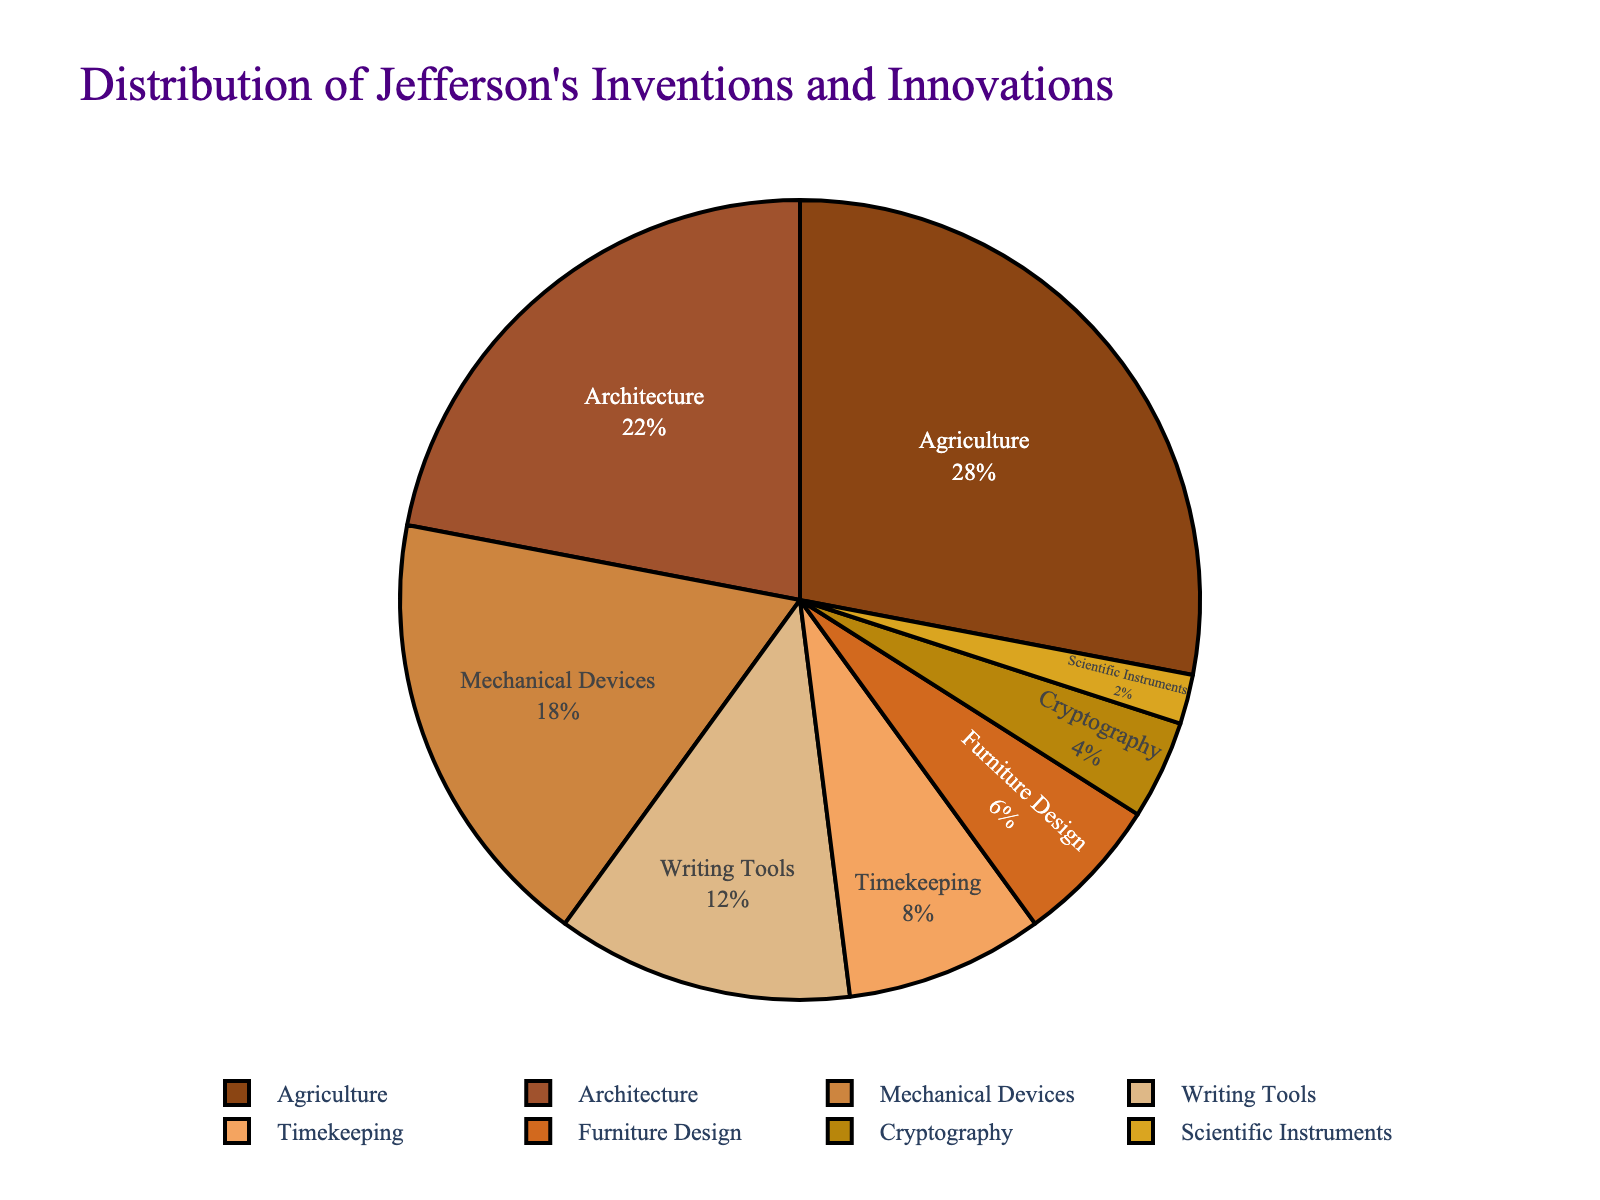What percentage of Jefferson's innovations were related to architecture? Look at the 'Architecture' section in the pie chart, which lists the percentage directly.
Answer: 22% How much larger is the percentage of agriculture-related innovations compared to those in cryptography? Subtract the percentage of cryptography innovations (4%) from the percentage of agriculture innovations (28%). (28% - 4% = 24%).
Answer: 24% What three fields have the largest portions in the pie chart? Identify the three largest segments by their percentage values: Agriculture (28%), Architecture (22%), and Mechanical Devices (18%).
Answer: Agriculture, Architecture, Mechanical Devices Which field has a smaller percentage, writing tools or timekeeping? Compare the 'Writing Tools' percentage (12%) to the 'Timekeeping' percentage (8%).
Answer: Timekeeping What is the combined percentage of Jefferson's innovations in furniture design and scientific instruments? Add the percentage values for 'Furniture Design' (6%) and 'Scientific Instruments' (2%). (6% + 2% = 8%).
Answer: 8% How does the percentage of mechanical devices compare to that of writing tools? Compare the percentage of 'Mechanical Devices' (18%) with 'Writing Tools' (12%). 18% is greater than 12%.
Answer: Mechanical Devices > Writing Tools What is the difference between the largest and smallest fields in terms of innovations? Subtract the smallest percentage (Scientific Instruments, 2%) from the largest percentage (Agriculture, 28%). (28% - 2% = 26%).
Answer: 26% What percentage of Jefferson's innovations fall under fields related to design (including architecture and furniture design)? Add the percentages for 'Architecture' (22%) and 'Furniture Design' (6%). (22% + 6% = 28%).
Answer: 28% What field is represented by the fifth largest segment in the pie chart and what is its percentage? The fifth largest segment by percentage is 'Timekeeping', which is represented by 8%.
Answer: Timekeeping, 8% What are the two fields with the closest percentage of innovations, and what are their values? The two fields closest in percentage are 'Furniture Design' (6%) and 'Cryptography' (4%), with a difference of 2%.
Answer: Furniture Design (6%), Cryptography (4%) 